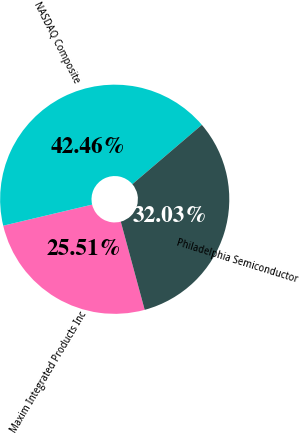<chart> <loc_0><loc_0><loc_500><loc_500><pie_chart><fcel>Maxim Integrated Products Inc<fcel>NASDAQ Composite<fcel>Philadelphia Semiconductor<nl><fcel>25.51%<fcel>42.46%<fcel>32.03%<nl></chart> 